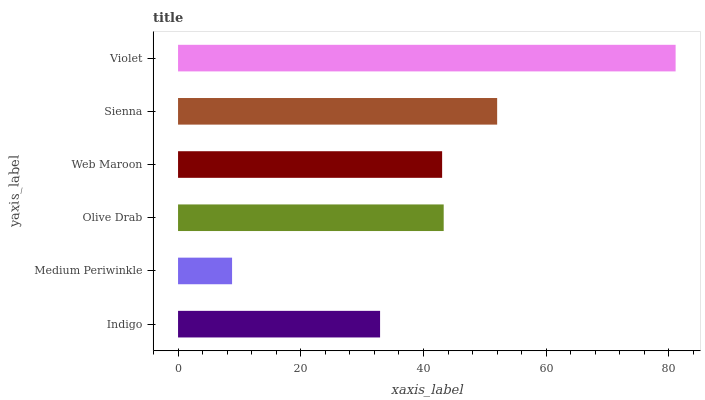Is Medium Periwinkle the minimum?
Answer yes or no. Yes. Is Violet the maximum?
Answer yes or no. Yes. Is Olive Drab the minimum?
Answer yes or no. No. Is Olive Drab the maximum?
Answer yes or no. No. Is Olive Drab greater than Medium Periwinkle?
Answer yes or no. Yes. Is Medium Periwinkle less than Olive Drab?
Answer yes or no. Yes. Is Medium Periwinkle greater than Olive Drab?
Answer yes or no. No. Is Olive Drab less than Medium Periwinkle?
Answer yes or no. No. Is Olive Drab the high median?
Answer yes or no. Yes. Is Web Maroon the low median?
Answer yes or no. Yes. Is Medium Periwinkle the high median?
Answer yes or no. No. Is Medium Periwinkle the low median?
Answer yes or no. No. 